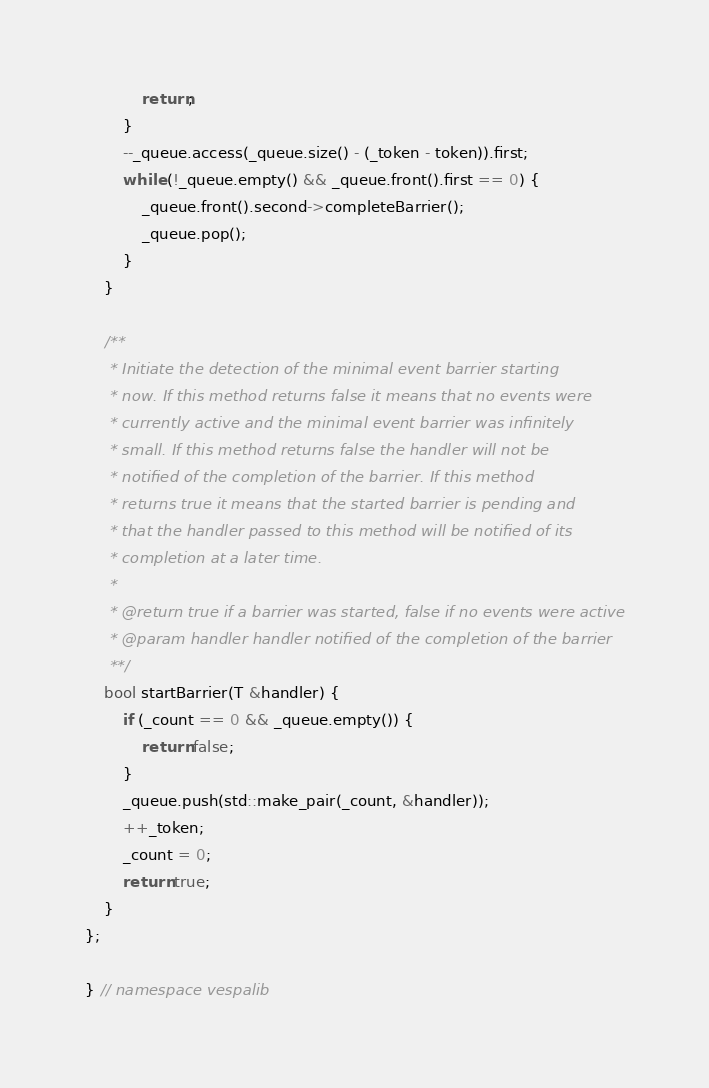Convert code to text. <code><loc_0><loc_0><loc_500><loc_500><_C++_>            return;
        }
        --_queue.access(_queue.size() - (_token - token)).first;
        while (!_queue.empty() && _queue.front().first == 0) {
            _queue.front().second->completeBarrier();
            _queue.pop();
        }
    }

    /**
     * Initiate the detection of the minimal event barrier starting
     * now. If this method returns false it means that no events were
     * currently active and the minimal event barrier was infinitely
     * small. If this method returns false the handler will not be
     * notified of the completion of the barrier. If this method
     * returns true it means that the started barrier is pending and
     * that the handler passed to this method will be notified of its
     * completion at a later time.
     *
     * @return true if a barrier was started, false if no events were active
     * @param handler handler notified of the completion of the barrier
     **/
    bool startBarrier(T &handler) {
        if (_count == 0 && _queue.empty()) {
            return false;
        }
        _queue.push(std::make_pair(_count, &handler));
        ++_token;
        _count = 0;
        return true;
    }
};

} // namespace vespalib

</code> 